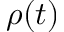<formula> <loc_0><loc_0><loc_500><loc_500>\rho ( t )</formula> 